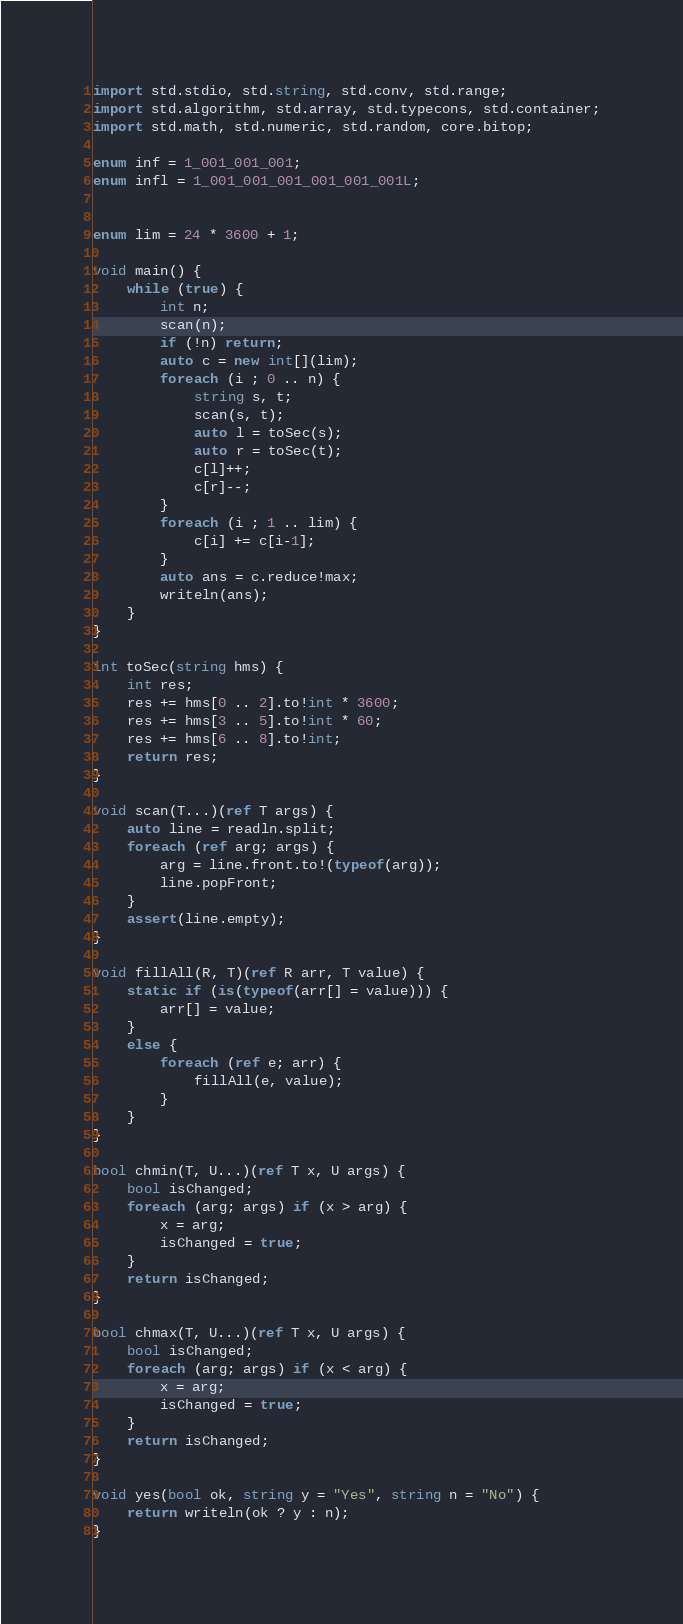Convert code to text. <code><loc_0><loc_0><loc_500><loc_500><_D_>import std.stdio, std.string, std.conv, std.range;
import std.algorithm, std.array, std.typecons, std.container;
import std.math, std.numeric, std.random, core.bitop;

enum inf = 1_001_001_001;
enum infl = 1_001_001_001_001_001_001L;


enum lim = 24 * 3600 + 1;

void main() {
    while (true) {
        int n;
        scan(n);
        if (!n) return;
        auto c = new int[](lim);
        foreach (i ; 0 .. n) {
            string s, t;
            scan(s, t);
            auto l = toSec(s);
            auto r = toSec(t);
            c[l]++;
            c[r]--;
        }
        foreach (i ; 1 .. lim) {
            c[i] += c[i-1];
        }
        auto ans = c.reduce!max;
        writeln(ans);
    }
}

int toSec(string hms) {
    int res;
    res += hms[0 .. 2].to!int * 3600;
    res += hms[3 .. 5].to!int * 60;
    res += hms[6 .. 8].to!int;
    return res;
}

void scan(T...)(ref T args) {
    auto line = readln.split;
    foreach (ref arg; args) {
        arg = line.front.to!(typeof(arg));
        line.popFront;
    }
    assert(line.empty);
}

void fillAll(R, T)(ref R arr, T value) {
    static if (is(typeof(arr[] = value))) {
        arr[] = value;
    }
    else {
        foreach (ref e; arr) {
            fillAll(e, value);
        }
    }
}

bool chmin(T, U...)(ref T x, U args) {
    bool isChanged;
    foreach (arg; args) if (x > arg) {
        x = arg;
        isChanged = true;
    }
    return isChanged;
}

bool chmax(T, U...)(ref T x, U args) {
    bool isChanged;
    foreach (arg; args) if (x < arg) {
        x = arg;
        isChanged = true;
    }
    return isChanged;
}

void yes(bool ok, string y = "Yes", string n = "No") {
    return writeln(ok ? y : n);
}
</code> 